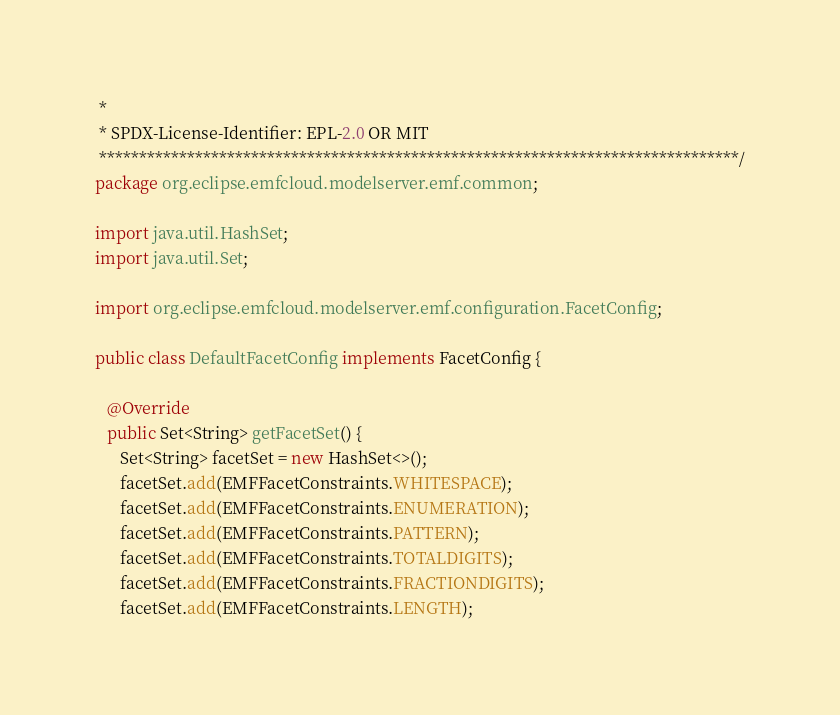<code> <loc_0><loc_0><loc_500><loc_500><_Java_> *
 * SPDX-License-Identifier: EPL-2.0 OR MIT
 ********************************************************************************/
package org.eclipse.emfcloud.modelserver.emf.common;

import java.util.HashSet;
import java.util.Set;

import org.eclipse.emfcloud.modelserver.emf.configuration.FacetConfig;

public class DefaultFacetConfig implements FacetConfig {

   @Override
   public Set<String> getFacetSet() {
      Set<String> facetSet = new HashSet<>();
      facetSet.add(EMFFacetConstraints.WHITESPACE);
      facetSet.add(EMFFacetConstraints.ENUMERATION);
      facetSet.add(EMFFacetConstraints.PATTERN);
      facetSet.add(EMFFacetConstraints.TOTALDIGITS);
      facetSet.add(EMFFacetConstraints.FRACTIONDIGITS);
      facetSet.add(EMFFacetConstraints.LENGTH);</code> 